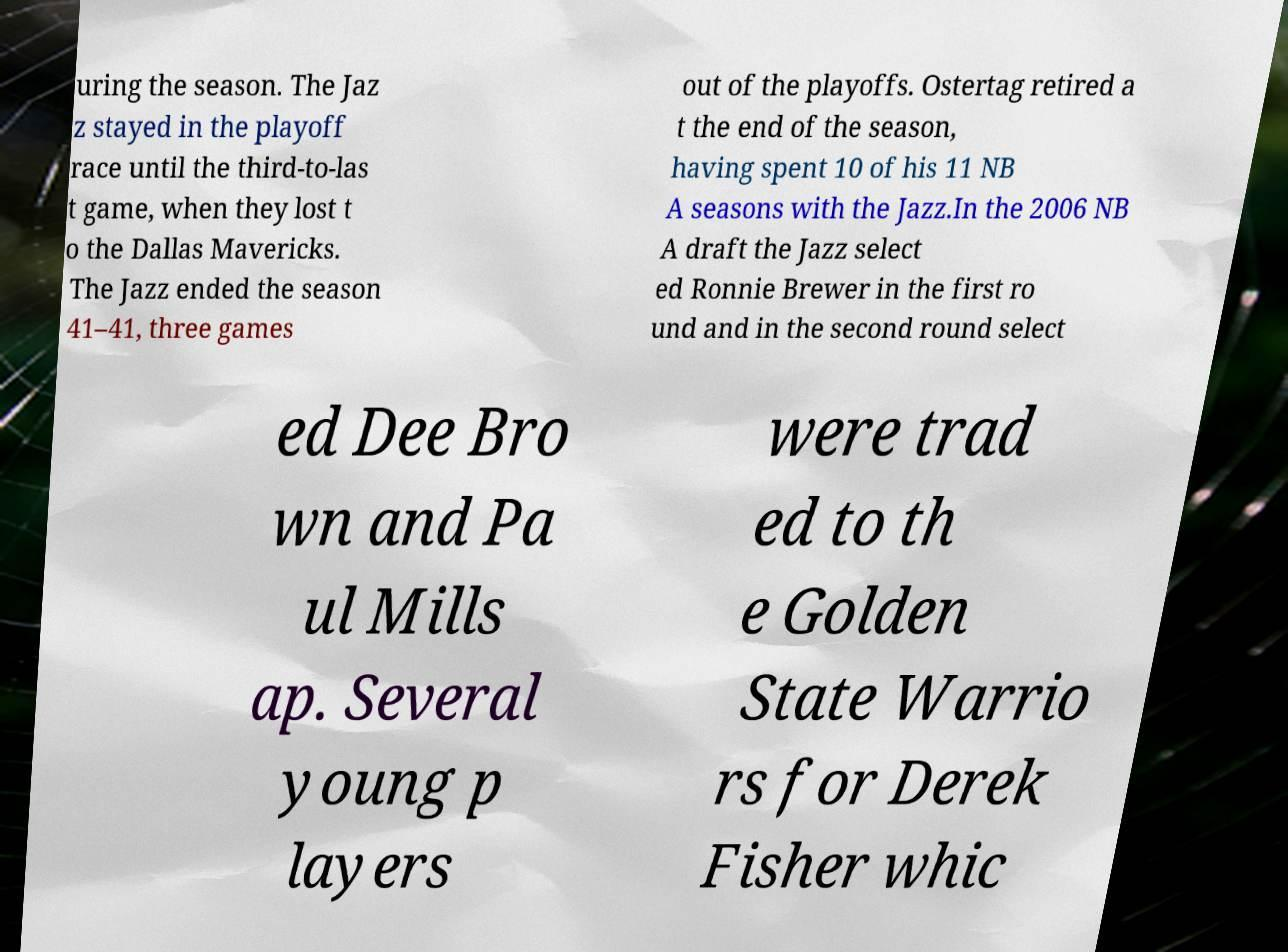Can you accurately transcribe the text from the provided image for me? uring the season. The Jaz z stayed in the playoff race until the third-to-las t game, when they lost t o the Dallas Mavericks. The Jazz ended the season 41–41, three games out of the playoffs. Ostertag retired a t the end of the season, having spent 10 of his 11 NB A seasons with the Jazz.In the 2006 NB A draft the Jazz select ed Ronnie Brewer in the first ro und and in the second round select ed Dee Bro wn and Pa ul Mills ap. Several young p layers were trad ed to th e Golden State Warrio rs for Derek Fisher whic 